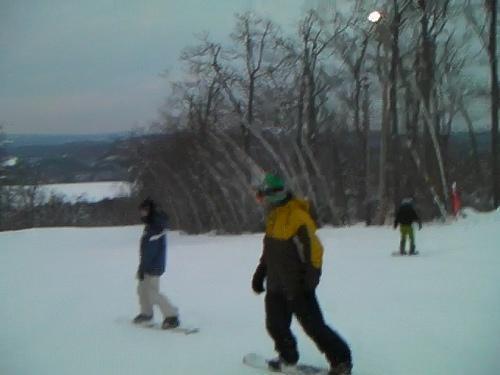How many people are there?
Give a very brief answer. 3. How many people are shown?
Give a very brief answer. 3. 